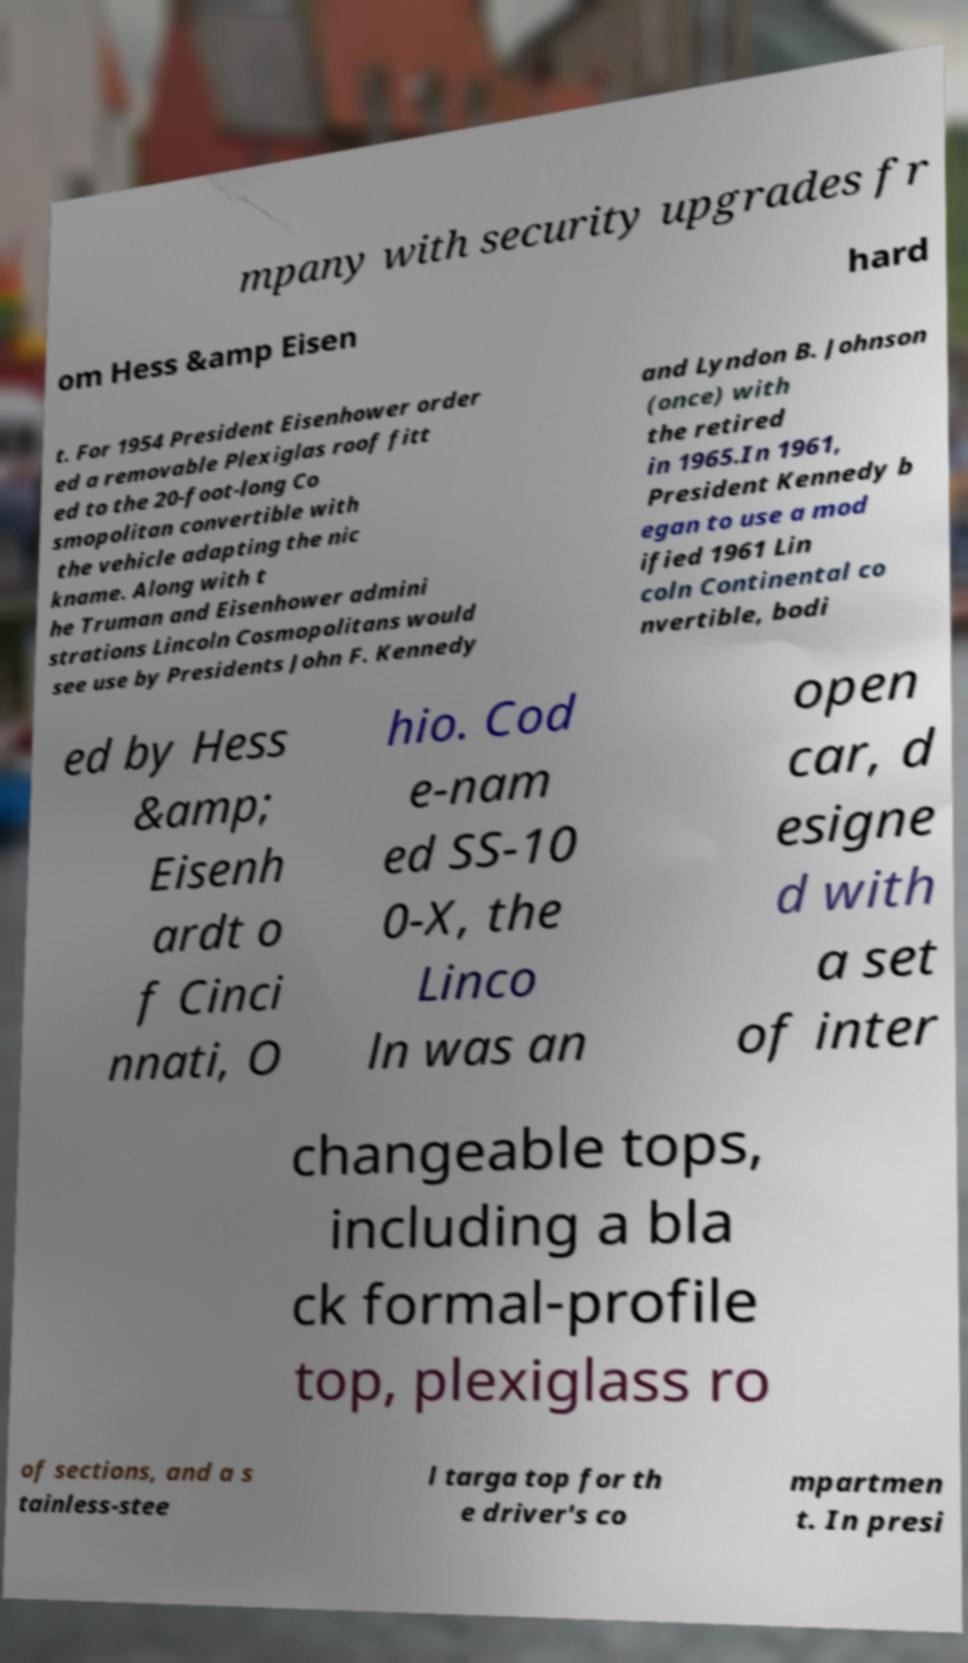Can you read and provide the text displayed in the image?This photo seems to have some interesting text. Can you extract and type it out for me? mpany with security upgrades fr om Hess &amp Eisen hard t. For 1954 President Eisenhower order ed a removable Plexiglas roof fitt ed to the 20-foot-long Co smopolitan convertible with the vehicle adapting the nic kname. Along with t he Truman and Eisenhower admini strations Lincoln Cosmopolitans would see use by Presidents John F. Kennedy and Lyndon B. Johnson (once) with the retired in 1965.In 1961, President Kennedy b egan to use a mod ified 1961 Lin coln Continental co nvertible, bodi ed by Hess &amp; Eisenh ardt o f Cinci nnati, O hio. Cod e-nam ed SS-10 0-X, the Linco ln was an open car, d esigne d with a set of inter changeable tops, including a bla ck formal-profile top, plexiglass ro of sections, and a s tainless-stee l targa top for th e driver's co mpartmen t. In presi 